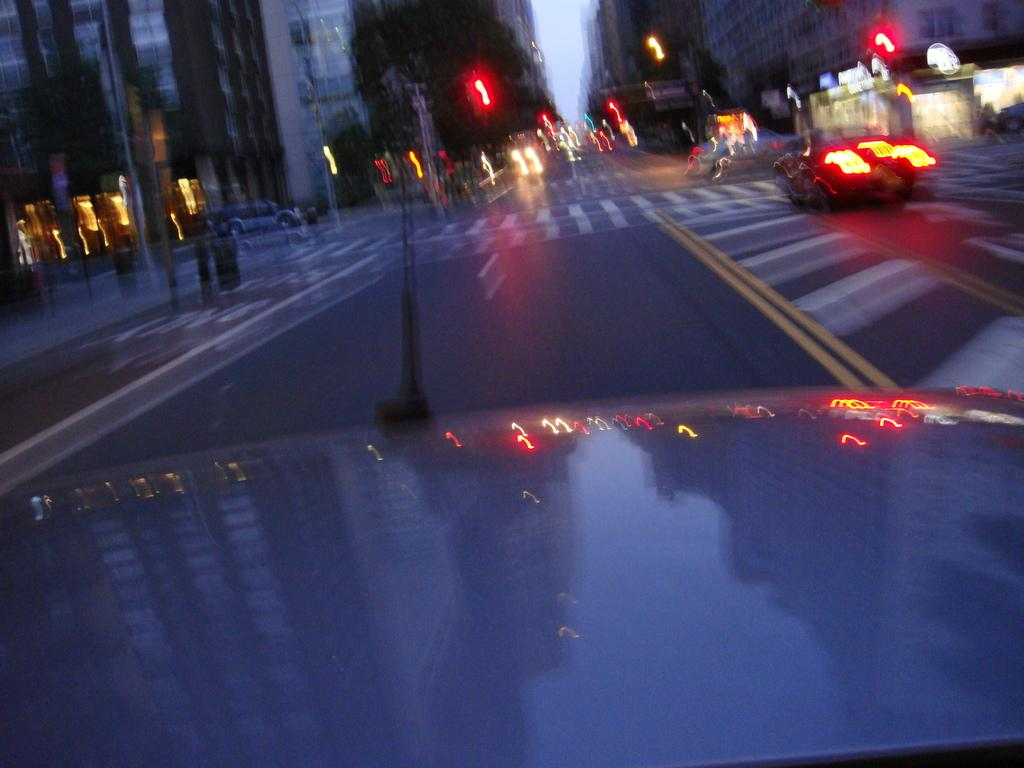What is happening on the road in the image? There are vehicles on the road in the image. What can be seen in the background of the image? There are street lights, buildings, and the sky visible in the background of the image. How is the image quality? The image is blurred. Are there any plantations visible in the image? There is no mention of a plantation in the provided facts, and therefore it cannot be determined if one is present in the image. How many babies are visible in the image? There are no babies present in the image; it features vehicles on the road and background elements. 